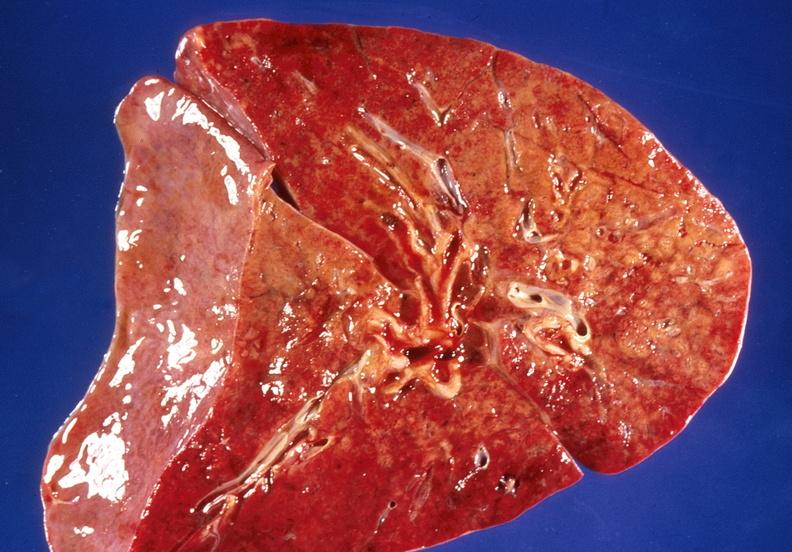s chronic myelogenous leukemia in blast crisis present?
Answer the question using a single word or phrase. No 